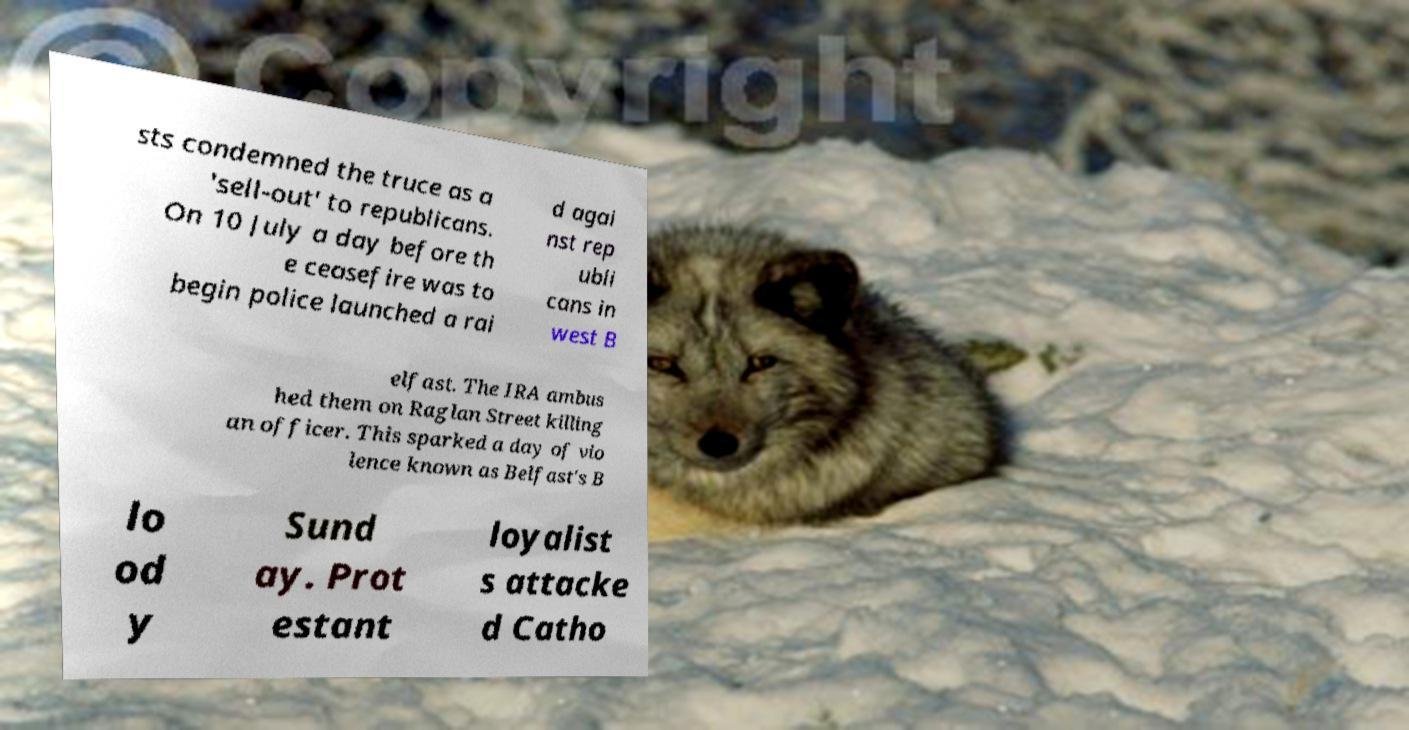Please identify and transcribe the text found in this image. sts condemned the truce as a 'sell-out' to republicans. On 10 July a day before th e ceasefire was to begin police launched a rai d agai nst rep ubli cans in west B elfast. The IRA ambus hed them on Raglan Street killing an officer. This sparked a day of vio lence known as Belfast's B lo od y Sund ay. Prot estant loyalist s attacke d Catho 